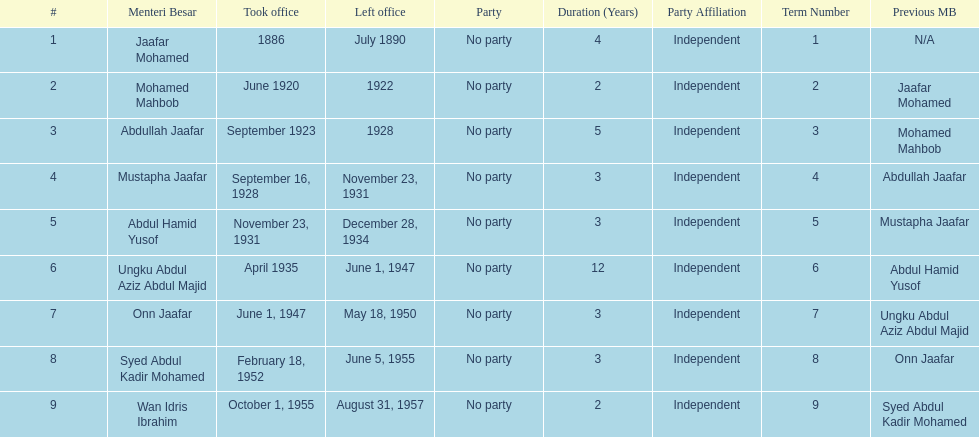What is the number of menteri besar that served 4 or more years? 3. 